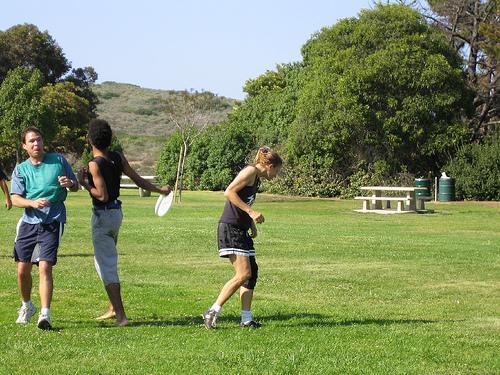How many people are at the park?
Give a very brief answer. 3. 